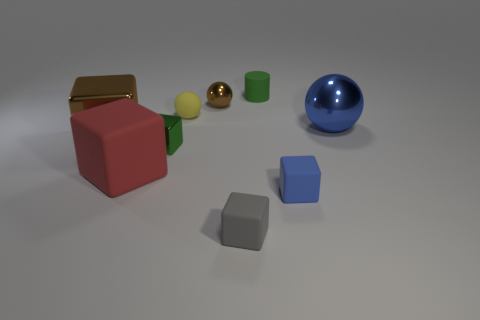Is there a tiny thing of the same color as the small metal block?
Provide a short and direct response. Yes. How many tiny things are to the left of the green cylinder?
Offer a very short reply. 4. What number of other objects are there of the same size as the gray matte block?
Your answer should be very brief. 5. Does the object that is to the right of the small blue matte block have the same material as the blue object in front of the red cube?
Your answer should be very brief. No. What is the color of the rubber cylinder that is the same size as the gray matte thing?
Give a very brief answer. Green. Are there any other things that have the same color as the large ball?
Make the answer very short. Yes. There is a brown shiny object that is on the left side of the green metallic cube that is to the left of the tiny metallic thing that is on the right side of the small yellow matte object; how big is it?
Keep it short and to the point. Large. The large thing that is to the left of the yellow sphere and behind the large red rubber block is what color?
Your response must be concise. Brown. What is the size of the blue object behind the brown metal cube?
Ensure brevity in your answer.  Large. What number of gray objects are made of the same material as the big brown block?
Provide a succinct answer. 0. 